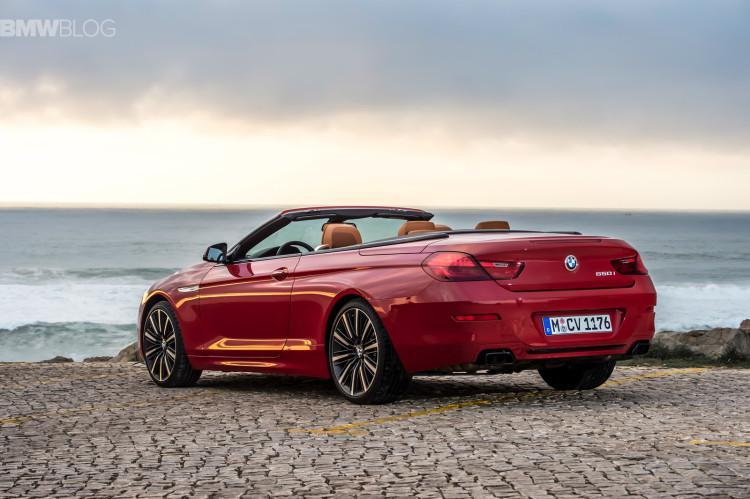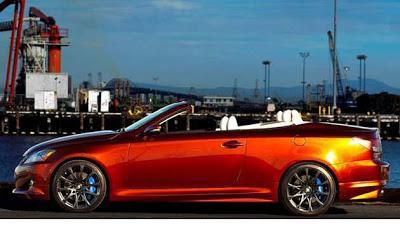The first image is the image on the left, the second image is the image on the right. For the images displayed, is the sentence "Right image shows a red forward-angled convertible alongside a rocky shoreline." factually correct? Answer yes or no. No. The first image is the image on the left, the second image is the image on the right. Analyze the images presented: Is the assertion "In one image, a red convertible is near a body of water, while in a second image, a red car is parked in front of an area of greenery and a white structure." valid? Answer yes or no. No. 